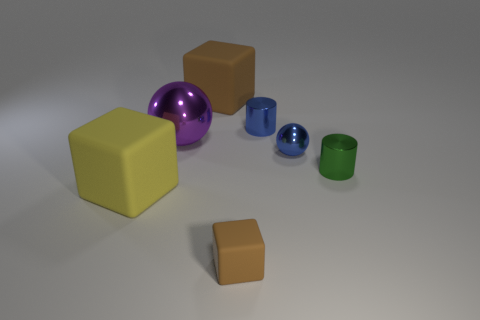Add 1 small gray metal objects. How many objects exist? 8 Subtract all blocks. How many objects are left? 4 Add 2 small brown rubber things. How many small brown rubber things are left? 3 Add 3 purple metallic balls. How many purple metallic balls exist? 4 Subtract 0 yellow cylinders. How many objects are left? 7 Subtract all blue metal balls. Subtract all yellow blocks. How many objects are left? 5 